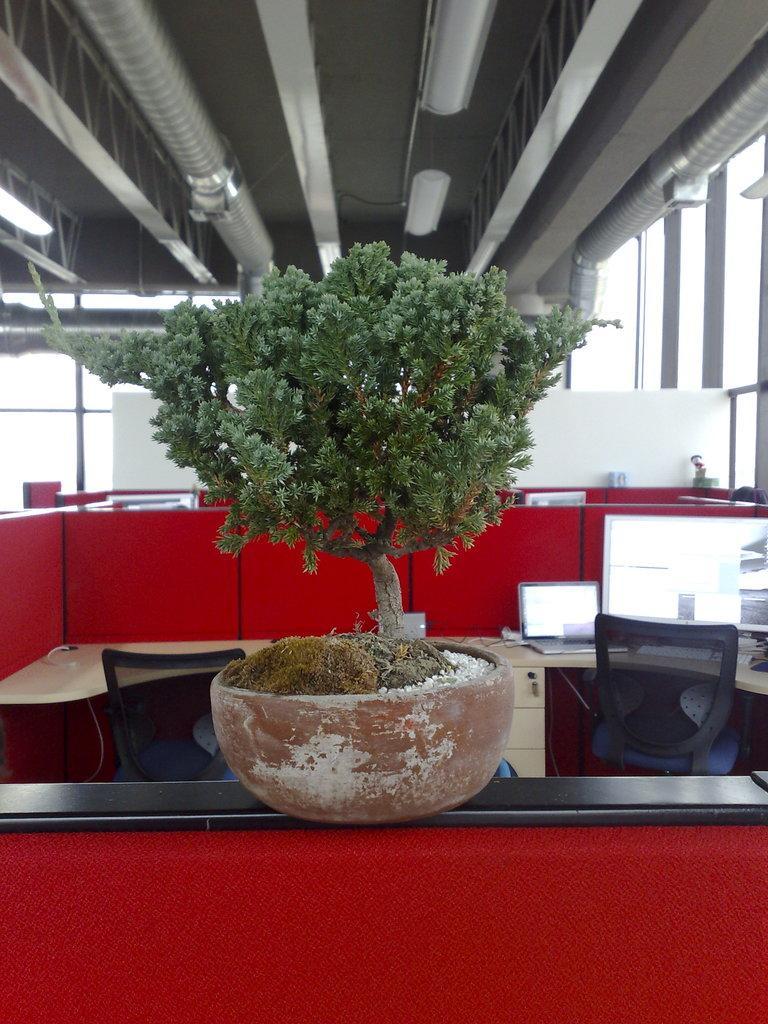Can you describe this image briefly? This is an inside view. Here I can see a plant pot placed on a table. In the background there are many tables, chairs and monitors and also I can see the glass windows. On the right side there is a person. At the top of the image there are few metal objects attached to the ceiling. 